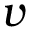Convert formula to latex. <formula><loc_0><loc_0><loc_500><loc_500>\boldsymbol v</formula> 